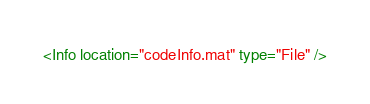<code> <loc_0><loc_0><loc_500><loc_500><_XML_><Info location="codeInfo.mat" type="File" /></code> 